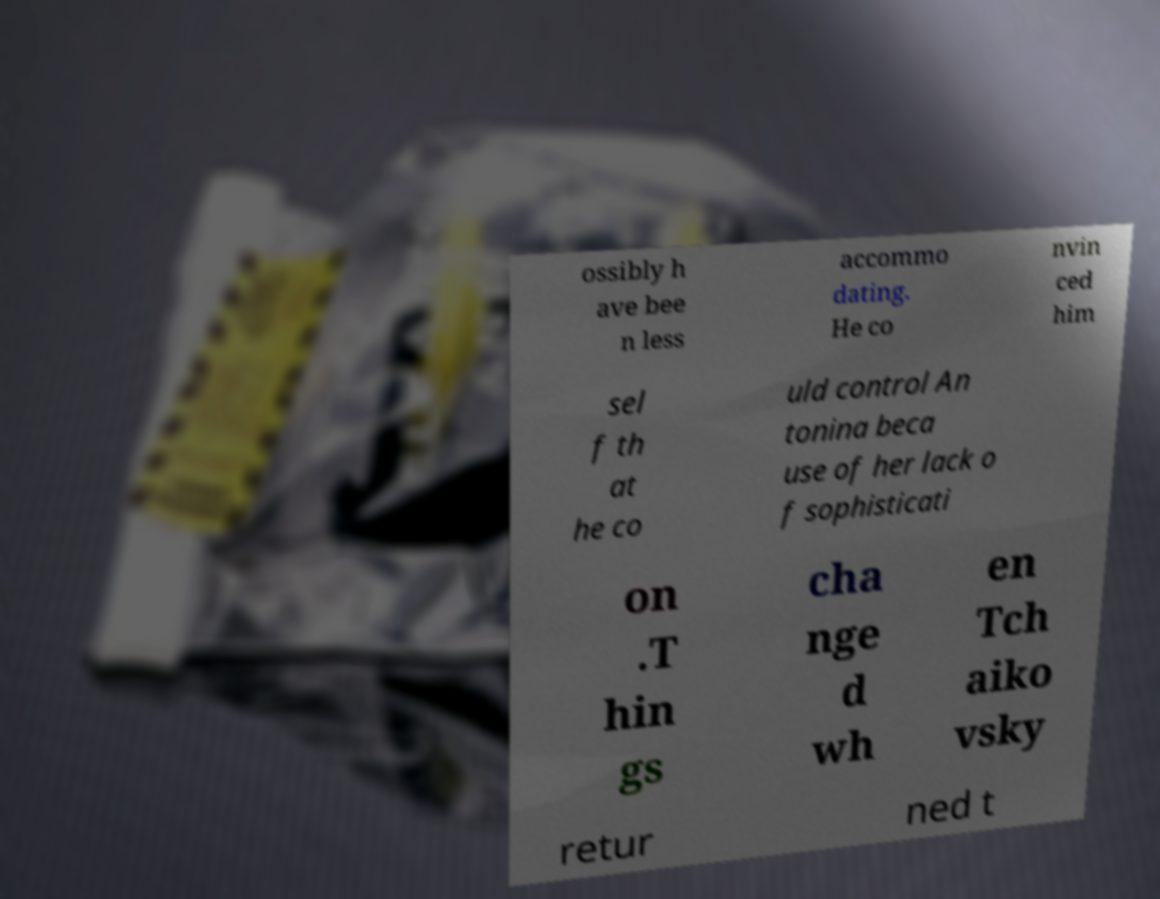Can you accurately transcribe the text from the provided image for me? ossibly h ave bee n less accommo dating. He co nvin ced him sel f th at he co uld control An tonina beca use of her lack o f sophisticati on .T hin gs cha nge d wh en Tch aiko vsky retur ned t 